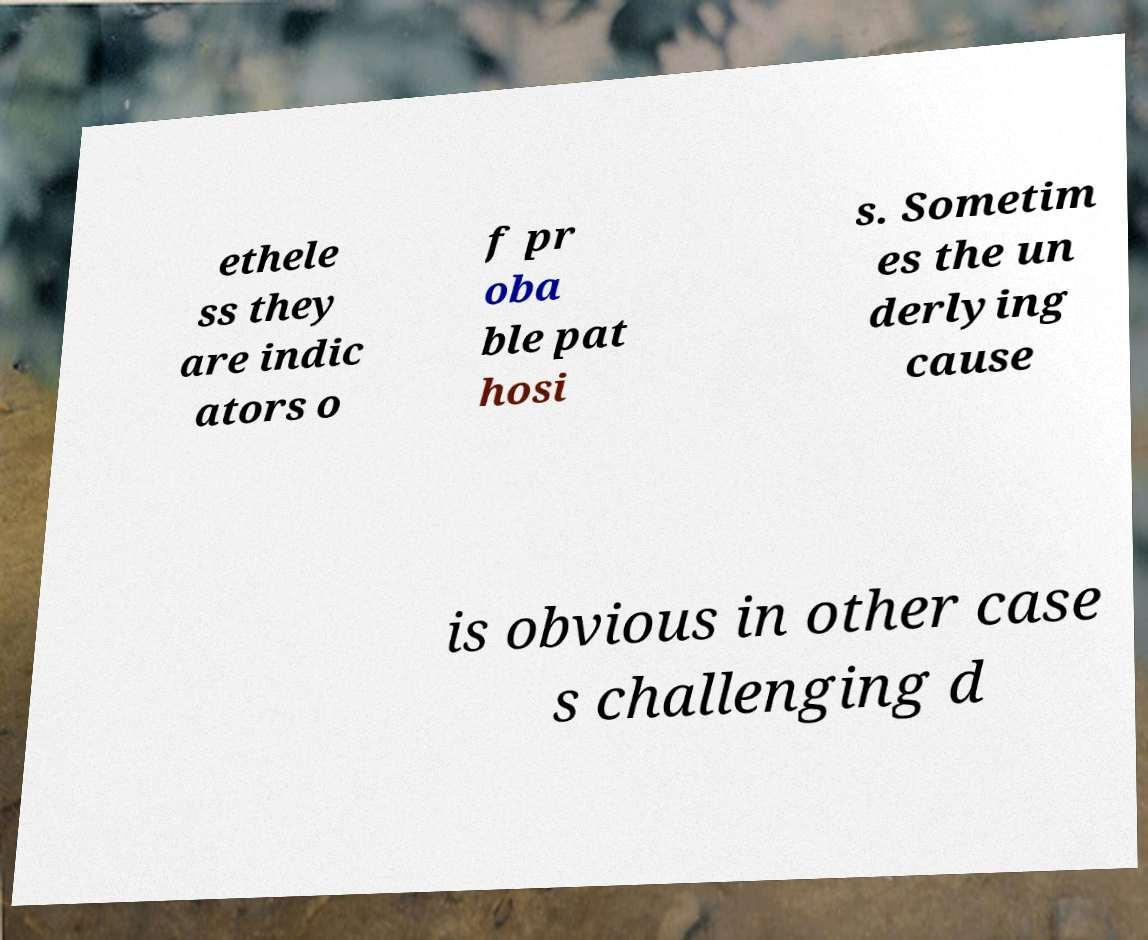Could you extract and type out the text from this image? ethele ss they are indic ators o f pr oba ble pat hosi s. Sometim es the un derlying cause is obvious in other case s challenging d 